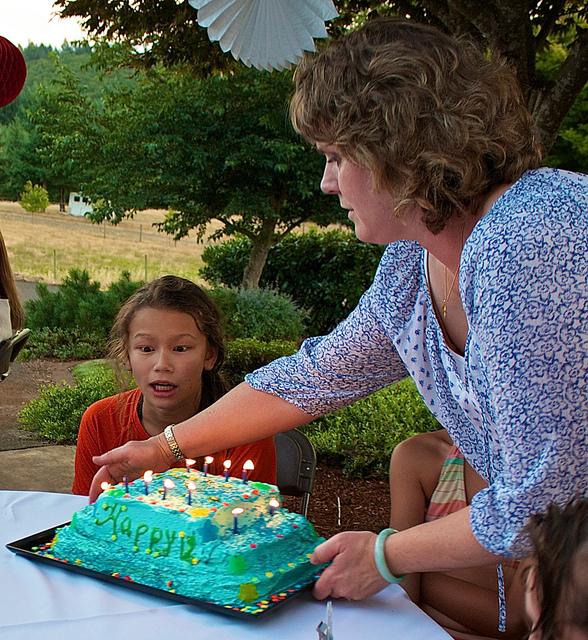Would this top be considered sleeveless?
Keep it brief. No. How old is the girl blowing out the candles?
Give a very brief answer. 9. Which function is this?
Write a very short answer. Birthday. What is the woman on the right holding?
Keep it brief. Cake. What is the celebration?
Short answer required. Birthday. How many bracelets is the woman on the right wearing?
Quick response, please. 2. 